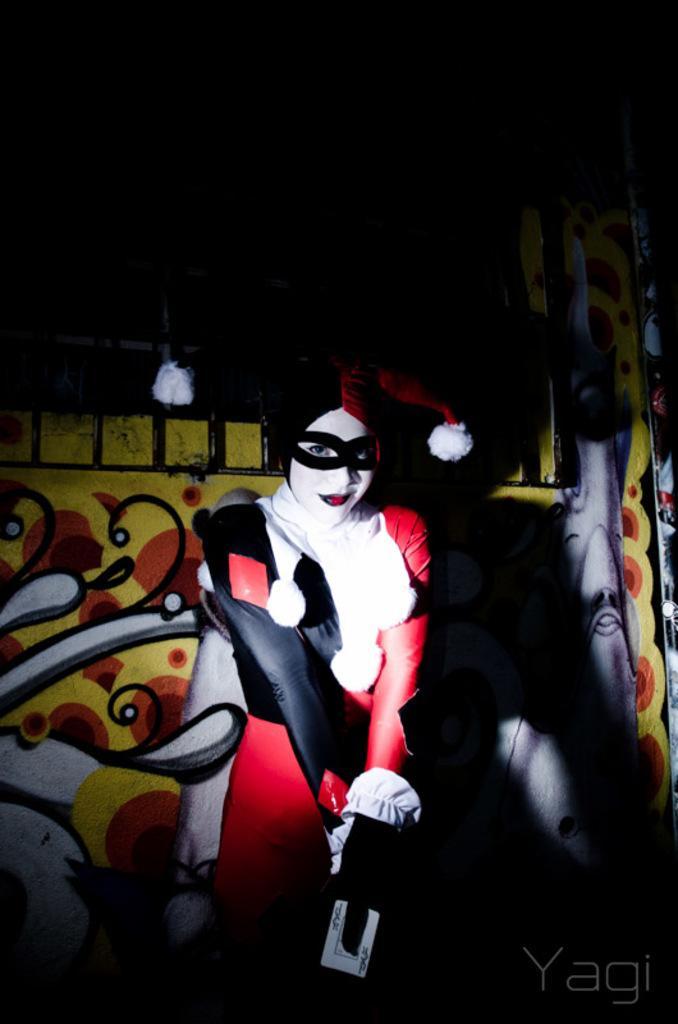How would you summarize this image in a sentence or two? In the center of this picture we can see a person wearing a costume and seems to be standing. In the background we can see the pictures of some objects which seems to be on the wall. In the bottom right corner we can see the watermark on the image. 